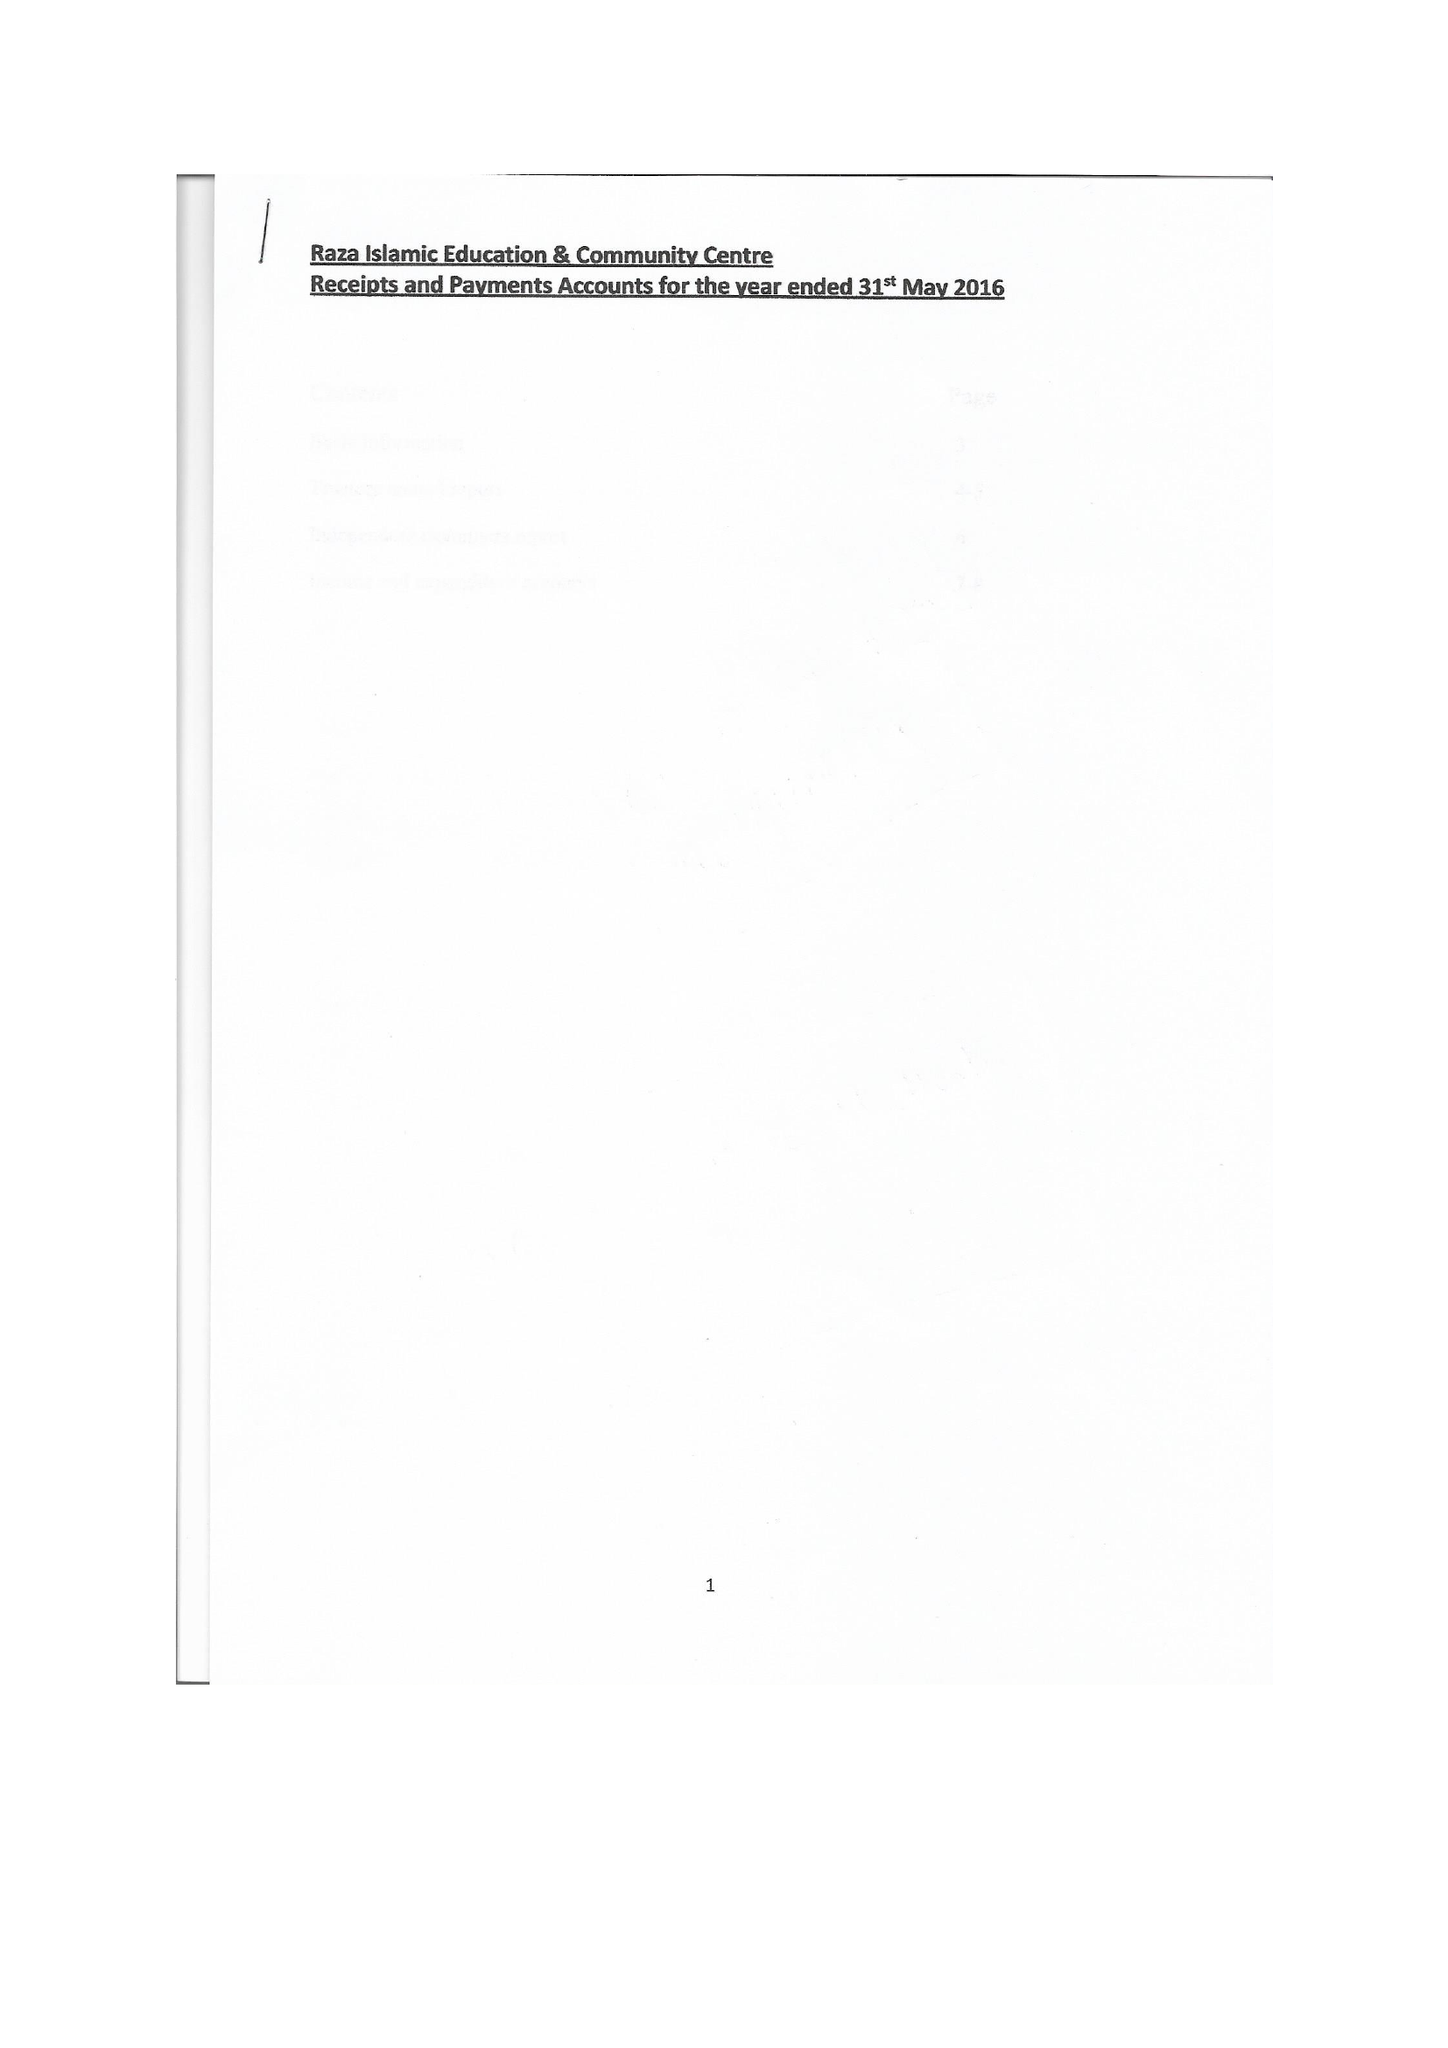What is the value for the income_annually_in_british_pounds?
Answer the question using a single word or phrase. 41152.00 